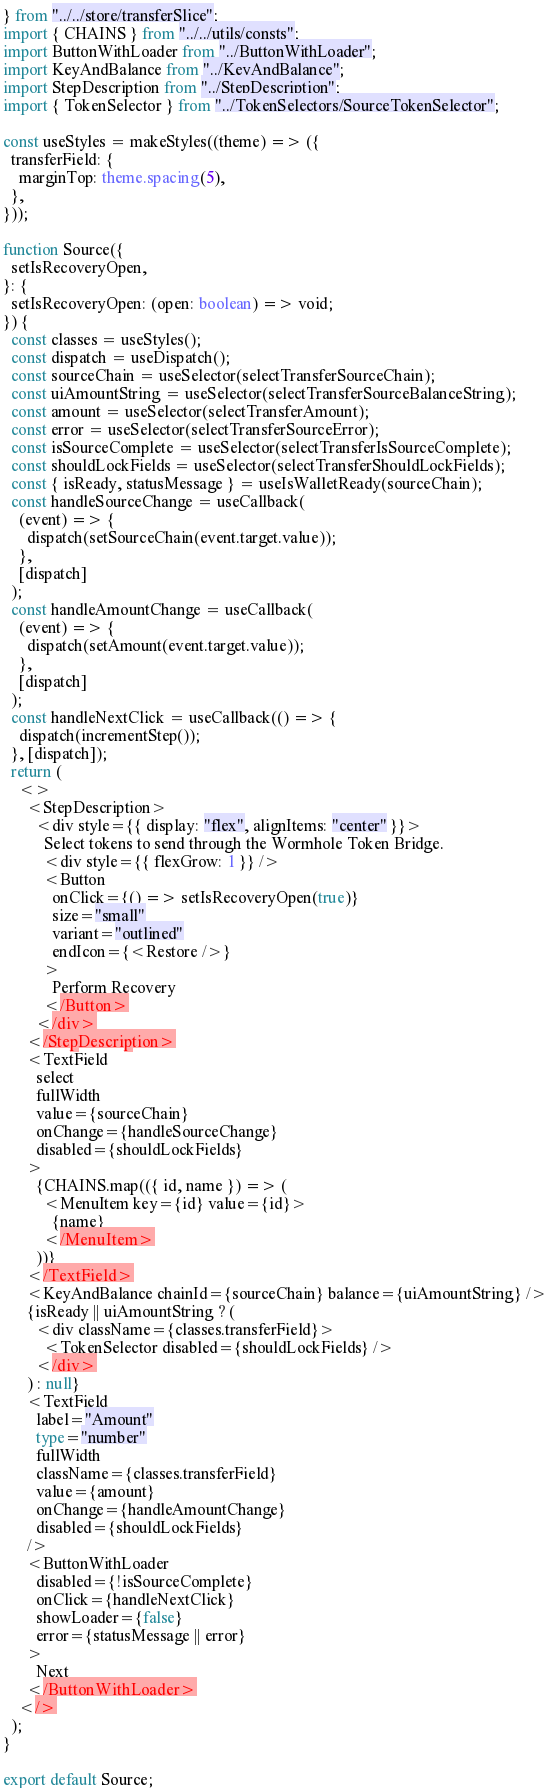Convert code to text. <code><loc_0><loc_0><loc_500><loc_500><_TypeScript_>} from "../../store/transferSlice";
import { CHAINS } from "../../utils/consts";
import ButtonWithLoader from "../ButtonWithLoader";
import KeyAndBalance from "../KeyAndBalance";
import StepDescription from "../StepDescription";
import { TokenSelector } from "../TokenSelectors/SourceTokenSelector";

const useStyles = makeStyles((theme) => ({
  transferField: {
    marginTop: theme.spacing(5),
  },
}));

function Source({
  setIsRecoveryOpen,
}: {
  setIsRecoveryOpen: (open: boolean) => void;
}) {
  const classes = useStyles();
  const dispatch = useDispatch();
  const sourceChain = useSelector(selectTransferSourceChain);
  const uiAmountString = useSelector(selectTransferSourceBalanceString);
  const amount = useSelector(selectTransferAmount);
  const error = useSelector(selectTransferSourceError);
  const isSourceComplete = useSelector(selectTransferIsSourceComplete);
  const shouldLockFields = useSelector(selectTransferShouldLockFields);
  const { isReady, statusMessage } = useIsWalletReady(sourceChain);
  const handleSourceChange = useCallback(
    (event) => {
      dispatch(setSourceChain(event.target.value));
    },
    [dispatch]
  );
  const handleAmountChange = useCallback(
    (event) => {
      dispatch(setAmount(event.target.value));
    },
    [dispatch]
  );
  const handleNextClick = useCallback(() => {
    dispatch(incrementStep());
  }, [dispatch]);
  return (
    <>
      <StepDescription>
        <div style={{ display: "flex", alignItems: "center" }}>
          Select tokens to send through the Wormhole Token Bridge.
          <div style={{ flexGrow: 1 }} />
          <Button
            onClick={() => setIsRecoveryOpen(true)}
            size="small"
            variant="outlined"
            endIcon={<Restore />}
          >
            Perform Recovery
          </Button>
        </div>
      </StepDescription>
      <TextField
        select
        fullWidth
        value={sourceChain}
        onChange={handleSourceChange}
        disabled={shouldLockFields}
      >
        {CHAINS.map(({ id, name }) => (
          <MenuItem key={id} value={id}>
            {name}
          </MenuItem>
        ))}
      </TextField>
      <KeyAndBalance chainId={sourceChain} balance={uiAmountString} />
      {isReady || uiAmountString ? (
        <div className={classes.transferField}>
          <TokenSelector disabled={shouldLockFields} />
        </div>
      ) : null}
      <TextField
        label="Amount"
        type="number"
        fullWidth
        className={classes.transferField}
        value={amount}
        onChange={handleAmountChange}
        disabled={shouldLockFields}
      />
      <ButtonWithLoader
        disabled={!isSourceComplete}
        onClick={handleNextClick}
        showLoader={false}
        error={statusMessage || error}
      >
        Next
      </ButtonWithLoader>
    </>
  );
}

export default Source;
</code> 